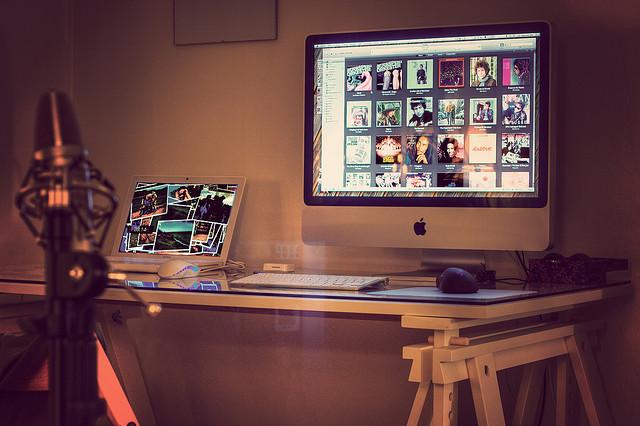Are these modern computers?
Keep it brief. Yes. Where is the keyboard and mouse?
Answer briefly. Desk. How many monitors are there?
Short answer required. 2. Is there a coffee cup on the desk?
Concise answer only. No. What is the brand of the large computer?
Be succinct. Apple. 